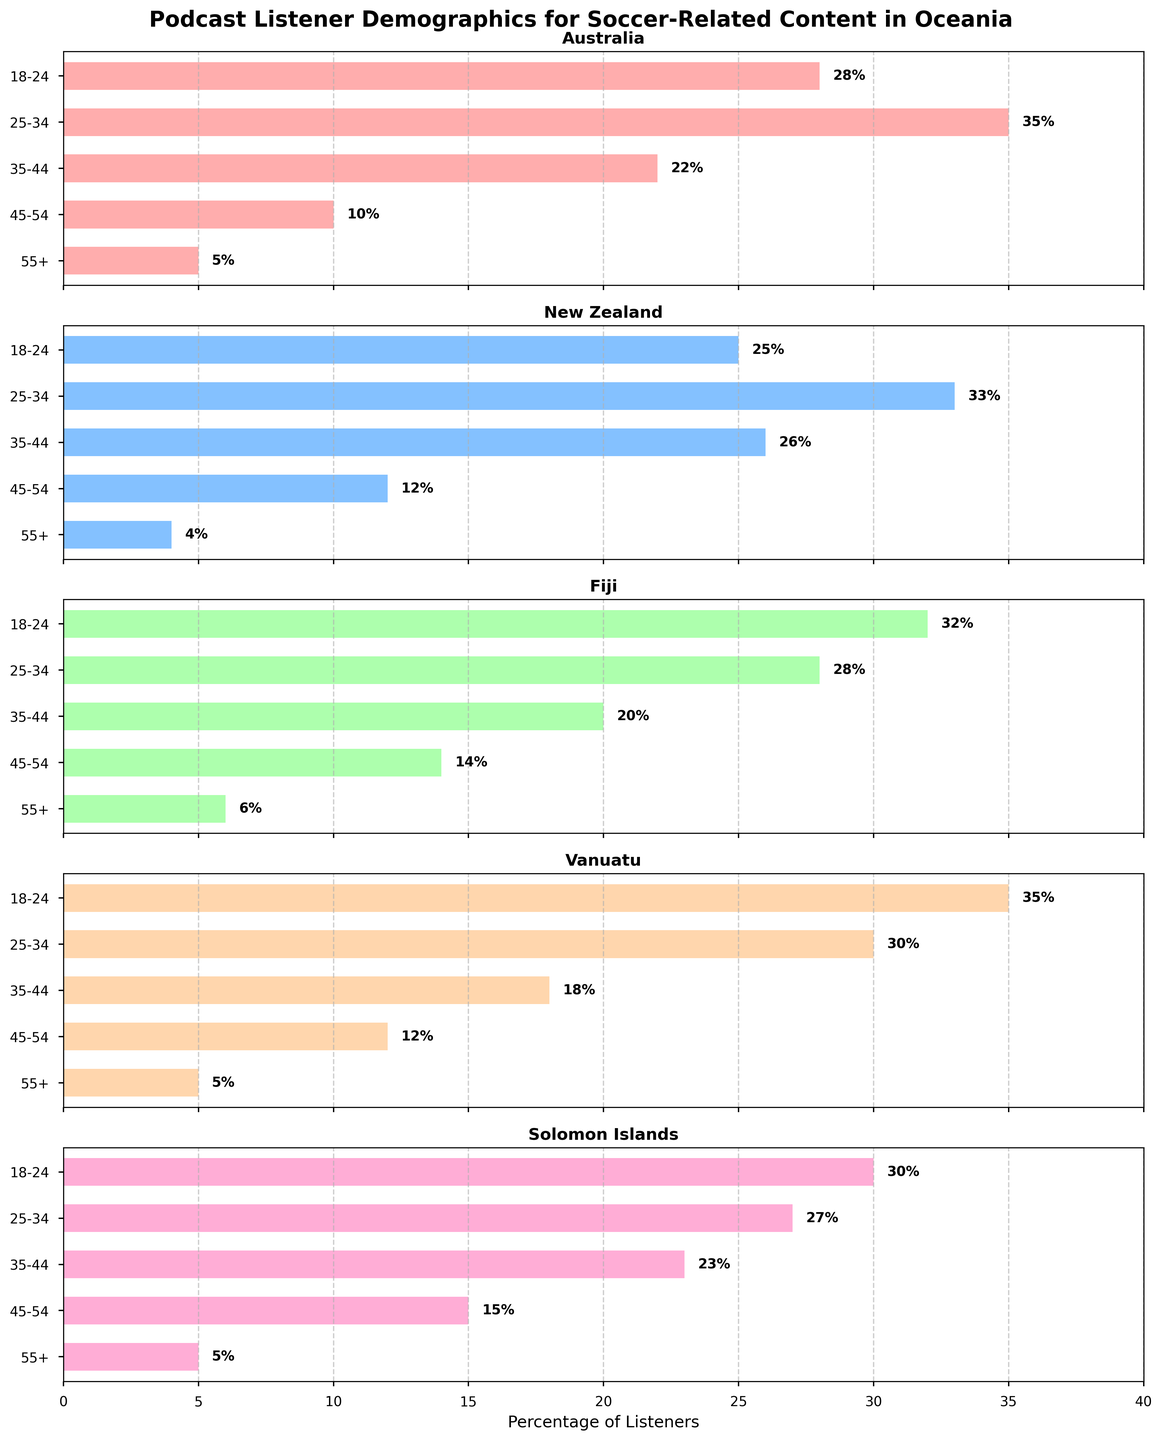What is the title of the figure? The title is prominently displayed at the top of the figure in a larger and bold font. It states, "Podcast Listener Demographics for Soccer-Related Content in Oceania."
Answer: Podcast Listener Demographics for Soccer-Related Content in Oceania What percentage of listeners aged 25-34 are from Australia? Look at the horizontal bar for the age group 25-34 in the subplot titled Australia. The bar's length and the text on the right side of the bar indicate the percentage.
Answer: 35% Among all countries, which age group has the lowest percentage of listeners? Compare the lengths and values of the bars across all subplots. The shortest bar across all subplots belongs to the age group 55+.
Answer: 55+ What is the combined percentage of podcast listeners aged 18-24 in Vanuatu and Fiji? Add the percentages of the listeners aged 18-24 from the Vanuatu and Fiji subplots: 35% and 32%, respectively. By summing these percentages, we get 35% + 32% = 67%.
Answer: 67% Which country has the highest percentage of listeners aged 18-24? Compare the lengths of the horizontal bars of the age group 18-24 across all subplots. The subplot for Vanuatu has the longest bar for this age group.
Answer: Vanuatu How does the percentage of listeners aged 45-54 compare between Australia and Solomon Islands? Observe the horizontal bars for the age group 45-54 in both the Australia and Solomon Islands subplots. Australia has a bar of 10%, while Solomon Islands has a bar of 15%. Hence, the percentage in Solomon Islands is higher.
Answer: Solomon Islands Which country has the most even distribution of listeners across all age groups? Look for the subplot where the lengths of the bars are relatively closer in value across each age group. New Zealand's subplot shows relatively even distribution compared to other countries.
Answer: New Zealand How many age groups have more than 30% listeners from Australia? Observe the Australia subplot and count the bars longer than 30%. The age groups 18-24 (28%) and 25-34 (35%) stand out.
Answer: 1 What percentage of listeners aged 35-44 in Vanuatu is more or less than in Fiji? Compare the bars for the 35-44 age group in both Vanuatu (18%) and Fiji (20%). The percentage in Vanuatu is 2% less than in Fiji.
Answer: 2% less Which country has the least percentage of listeners aged 25-34? Compare the lengths and values of the bars for the age group 25-34 across all subplots. Solomon Islands has the shortest bar for this age group with 27%.
Answer: Solomon Islands 